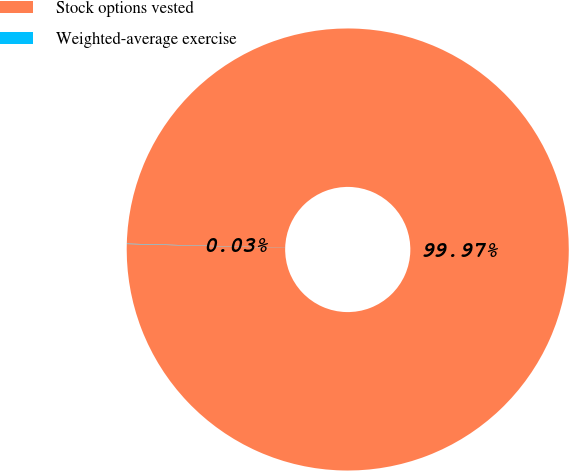<chart> <loc_0><loc_0><loc_500><loc_500><pie_chart><fcel>Stock options vested<fcel>Weighted-average exercise<nl><fcel>99.97%<fcel>0.03%<nl></chart> 